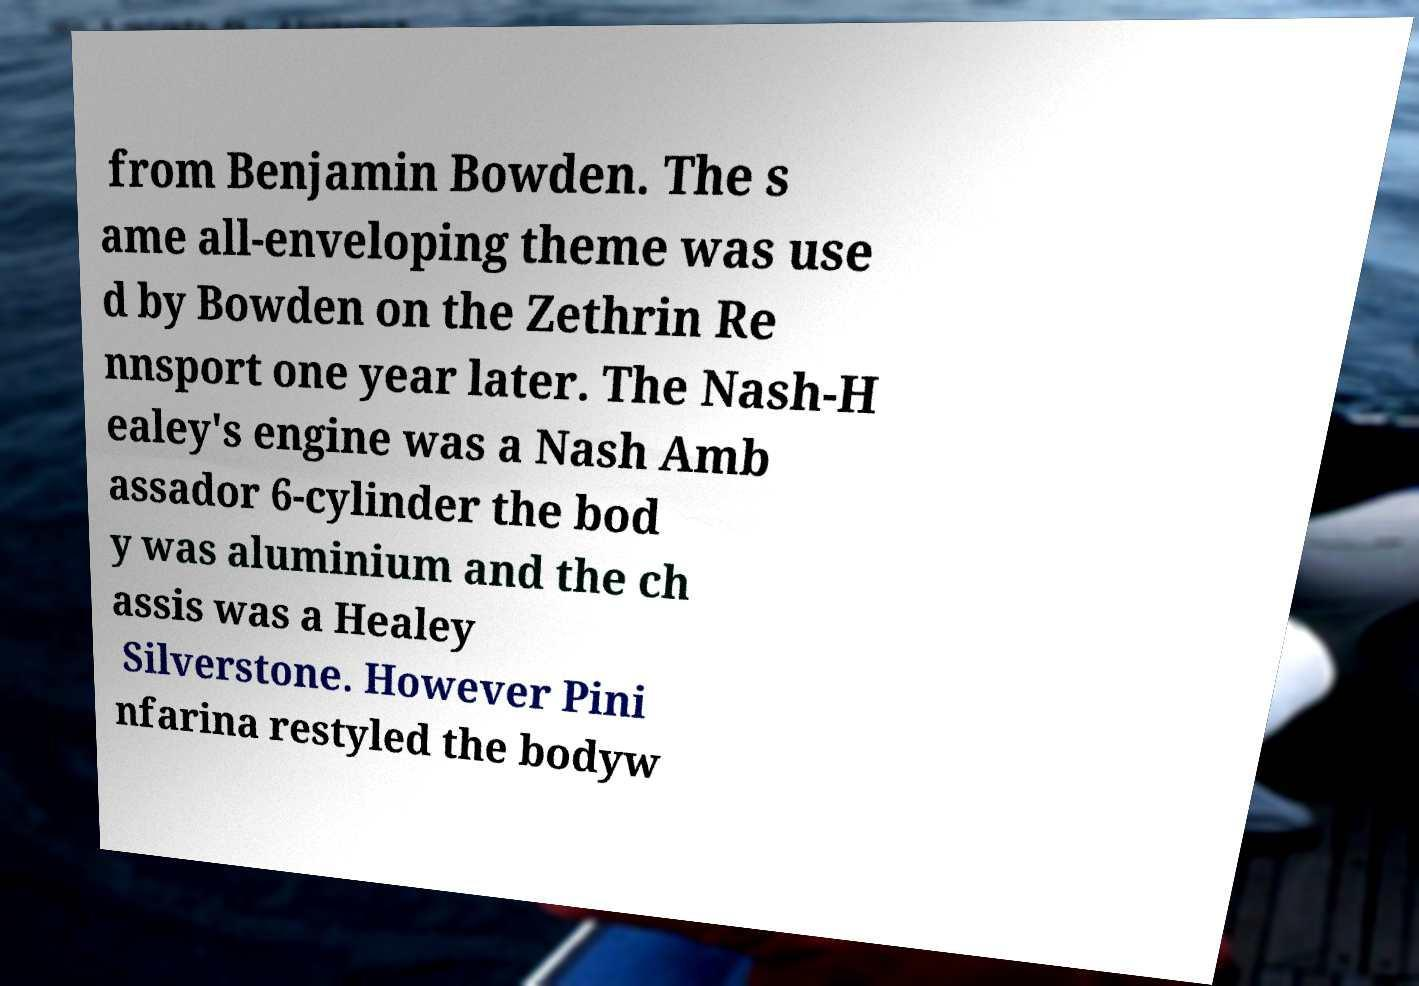Could you assist in decoding the text presented in this image and type it out clearly? from Benjamin Bowden. The s ame all-enveloping theme was use d by Bowden on the Zethrin Re nnsport one year later. The Nash-H ealey's engine was a Nash Amb assador 6-cylinder the bod y was aluminium and the ch assis was a Healey Silverstone. However Pini nfarina restyled the bodyw 